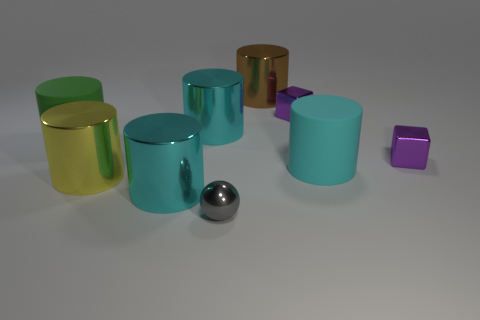There is a cyan shiny object that is in front of the big green matte thing; is its size the same as the cyan metal object behind the green rubber cylinder?
Keep it short and to the point. Yes. Is the number of big metal cylinders that are in front of the big brown shiny cylinder greater than the number of metallic objects that are behind the cyan rubber cylinder?
Provide a short and direct response. No. What number of large green rubber things are the same shape as the yellow thing?
Ensure brevity in your answer.  1. What is the material of the green thing that is the same size as the cyan rubber object?
Give a very brief answer. Rubber. Are there any small brown balls made of the same material as the large brown object?
Your answer should be very brief. No. Is the number of large brown cylinders that are on the left side of the large brown cylinder less than the number of tiny green cylinders?
Offer a terse response. No. What material is the small purple cube behind the big rubber object on the left side of the tiny gray sphere?
Make the answer very short. Metal. There is a big object that is behind the large cyan matte cylinder and right of the gray sphere; what is its shape?
Give a very brief answer. Cylinder. What number of other things are there of the same color as the small metallic sphere?
Ensure brevity in your answer.  0. How many objects are either objects left of the yellow shiny thing or green things?
Give a very brief answer. 1. 